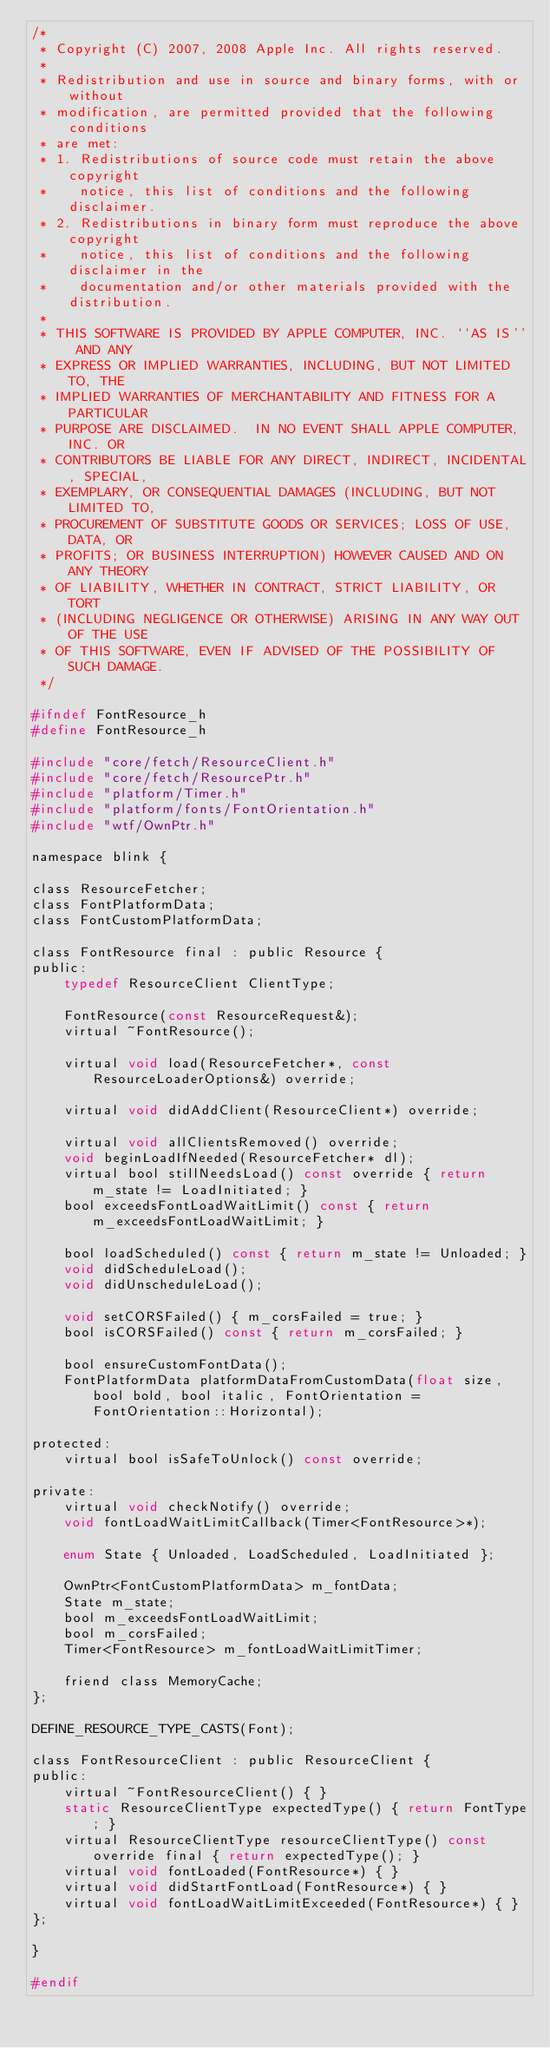Convert code to text. <code><loc_0><loc_0><loc_500><loc_500><_C_>/*
 * Copyright (C) 2007, 2008 Apple Inc. All rights reserved.
 *
 * Redistribution and use in source and binary forms, with or without
 * modification, are permitted provided that the following conditions
 * are met:
 * 1. Redistributions of source code must retain the above copyright
 *    notice, this list of conditions and the following disclaimer.
 * 2. Redistributions in binary form must reproduce the above copyright
 *    notice, this list of conditions and the following disclaimer in the
 *    documentation and/or other materials provided with the distribution.
 *
 * THIS SOFTWARE IS PROVIDED BY APPLE COMPUTER, INC. ``AS IS'' AND ANY
 * EXPRESS OR IMPLIED WARRANTIES, INCLUDING, BUT NOT LIMITED TO, THE
 * IMPLIED WARRANTIES OF MERCHANTABILITY AND FITNESS FOR A PARTICULAR
 * PURPOSE ARE DISCLAIMED.  IN NO EVENT SHALL APPLE COMPUTER, INC. OR
 * CONTRIBUTORS BE LIABLE FOR ANY DIRECT, INDIRECT, INCIDENTAL, SPECIAL,
 * EXEMPLARY, OR CONSEQUENTIAL DAMAGES (INCLUDING, BUT NOT LIMITED TO,
 * PROCUREMENT OF SUBSTITUTE GOODS OR SERVICES; LOSS OF USE, DATA, OR
 * PROFITS; OR BUSINESS INTERRUPTION) HOWEVER CAUSED AND ON ANY THEORY
 * OF LIABILITY, WHETHER IN CONTRACT, STRICT LIABILITY, OR TORT
 * (INCLUDING NEGLIGENCE OR OTHERWISE) ARISING IN ANY WAY OUT OF THE USE
 * OF THIS SOFTWARE, EVEN IF ADVISED OF THE POSSIBILITY OF SUCH DAMAGE.
 */

#ifndef FontResource_h
#define FontResource_h

#include "core/fetch/ResourceClient.h"
#include "core/fetch/ResourcePtr.h"
#include "platform/Timer.h"
#include "platform/fonts/FontOrientation.h"
#include "wtf/OwnPtr.h"

namespace blink {

class ResourceFetcher;
class FontPlatformData;
class FontCustomPlatformData;

class FontResource final : public Resource {
public:
    typedef ResourceClient ClientType;

    FontResource(const ResourceRequest&);
    virtual ~FontResource();

    virtual void load(ResourceFetcher*, const ResourceLoaderOptions&) override;

    virtual void didAddClient(ResourceClient*) override;

    virtual void allClientsRemoved() override;
    void beginLoadIfNeeded(ResourceFetcher* dl);
    virtual bool stillNeedsLoad() const override { return m_state != LoadInitiated; }
    bool exceedsFontLoadWaitLimit() const { return m_exceedsFontLoadWaitLimit; }

    bool loadScheduled() const { return m_state != Unloaded; }
    void didScheduleLoad();
    void didUnscheduleLoad();

    void setCORSFailed() { m_corsFailed = true; }
    bool isCORSFailed() const { return m_corsFailed; }

    bool ensureCustomFontData();
    FontPlatformData platformDataFromCustomData(float size, bool bold, bool italic, FontOrientation = FontOrientation::Horizontal);

protected:
    virtual bool isSafeToUnlock() const override;

private:
    virtual void checkNotify() override;
    void fontLoadWaitLimitCallback(Timer<FontResource>*);

    enum State { Unloaded, LoadScheduled, LoadInitiated };

    OwnPtr<FontCustomPlatformData> m_fontData;
    State m_state;
    bool m_exceedsFontLoadWaitLimit;
    bool m_corsFailed;
    Timer<FontResource> m_fontLoadWaitLimitTimer;

    friend class MemoryCache;
};

DEFINE_RESOURCE_TYPE_CASTS(Font);

class FontResourceClient : public ResourceClient {
public:
    virtual ~FontResourceClient() { }
    static ResourceClientType expectedType() { return FontType; }
    virtual ResourceClientType resourceClientType() const override final { return expectedType(); }
    virtual void fontLoaded(FontResource*) { }
    virtual void didStartFontLoad(FontResource*) { }
    virtual void fontLoadWaitLimitExceeded(FontResource*) { }
};

}

#endif
</code> 